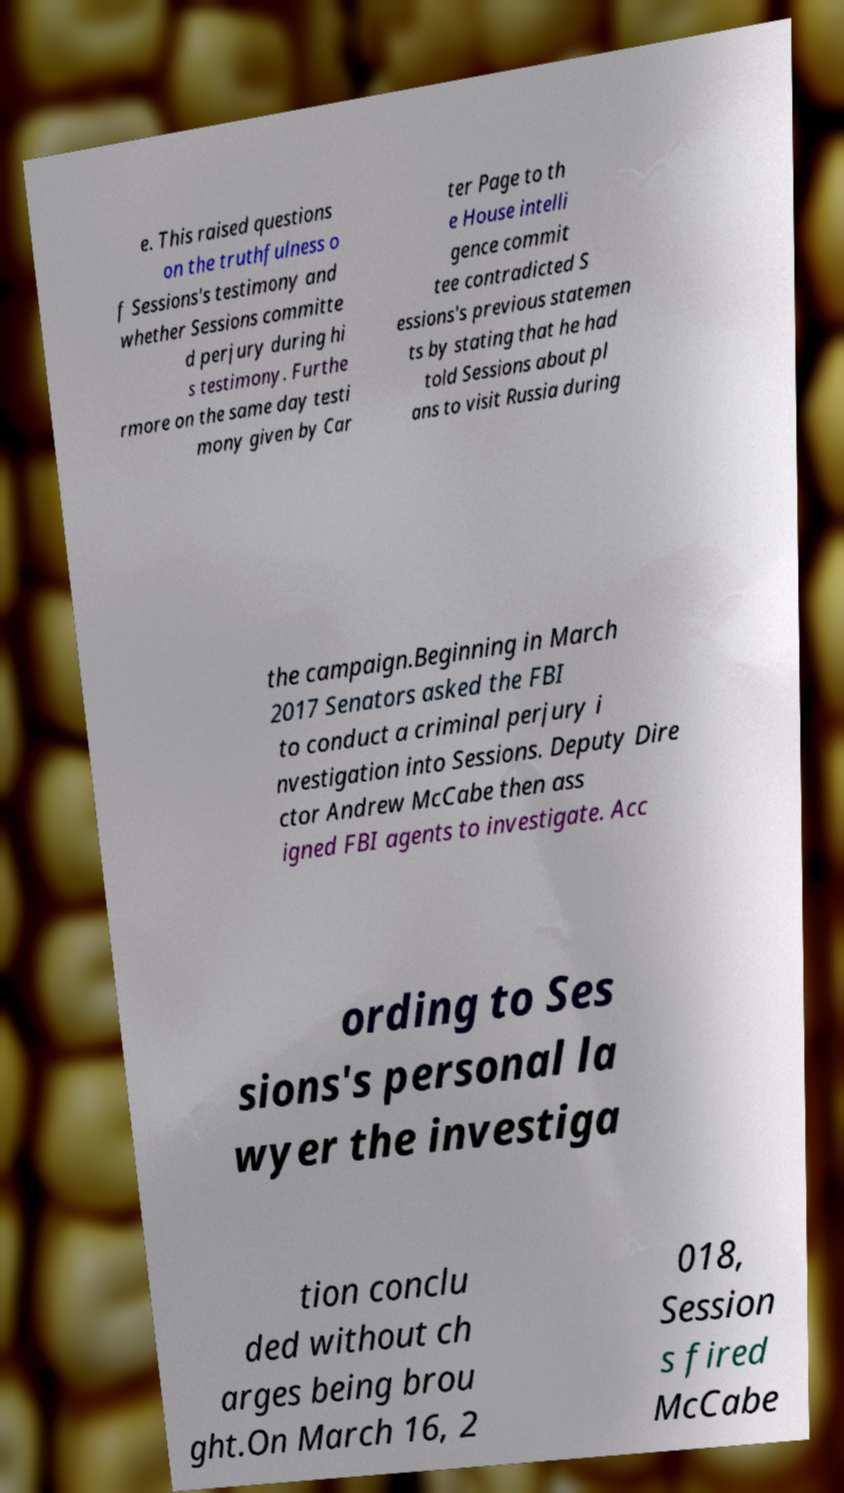Could you extract and type out the text from this image? e. This raised questions on the truthfulness o f Sessions's testimony and whether Sessions committe d perjury during hi s testimony. Furthe rmore on the same day testi mony given by Car ter Page to th e House intelli gence commit tee contradicted S essions's previous statemen ts by stating that he had told Sessions about pl ans to visit Russia during the campaign.Beginning in March 2017 Senators asked the FBI to conduct a criminal perjury i nvestigation into Sessions. Deputy Dire ctor Andrew McCabe then ass igned FBI agents to investigate. Acc ording to Ses sions's personal la wyer the investiga tion conclu ded without ch arges being brou ght.On March 16, 2 018, Session s fired McCabe 